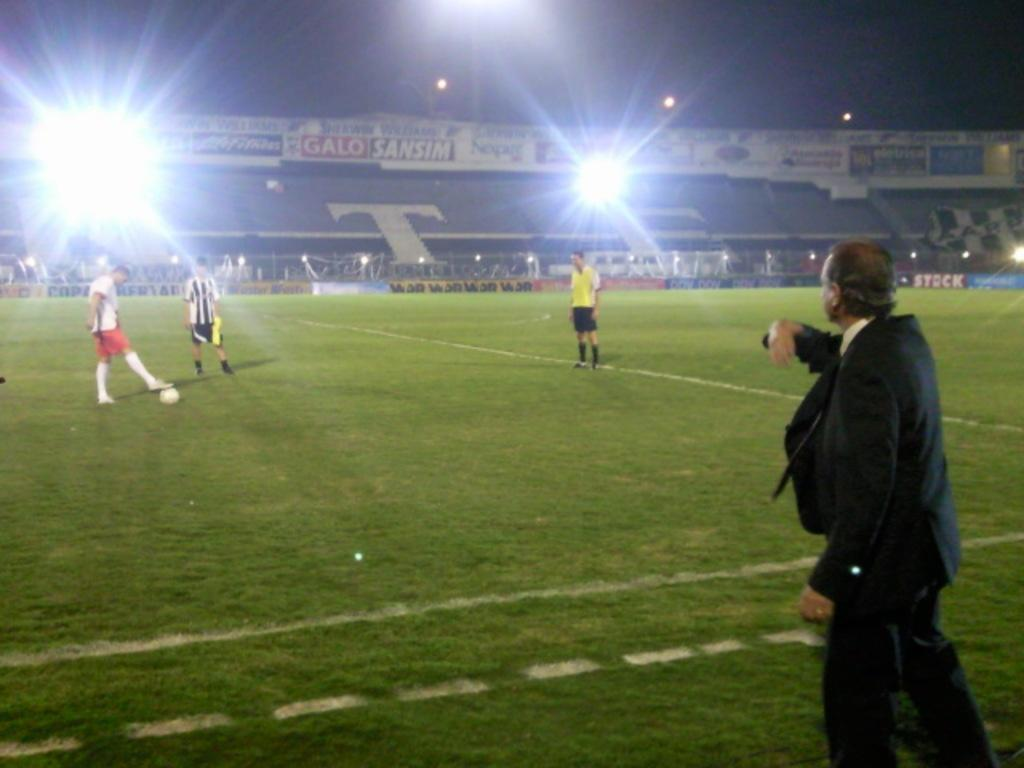<image>
Give a short and clear explanation of the subsequent image. A soccer field shows advertisements for Galo Sansim in the background. 